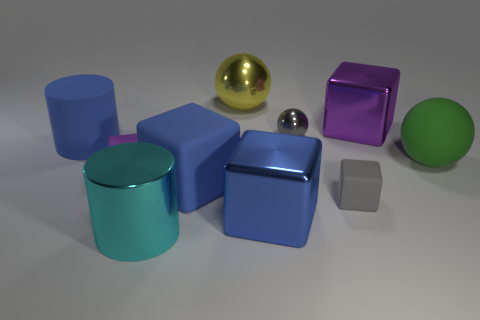Subtract all gray cubes. How many cubes are left? 4 Subtract all brown cubes. Subtract all purple spheres. How many cubes are left? 5 Subtract all spheres. How many objects are left? 7 Subtract 0 green cylinders. How many objects are left? 10 Subtract all big green rubber spheres. Subtract all yellow metallic objects. How many objects are left? 8 Add 4 tiny gray cubes. How many tiny gray cubes are left? 5 Add 4 rubber cylinders. How many rubber cylinders exist? 5 